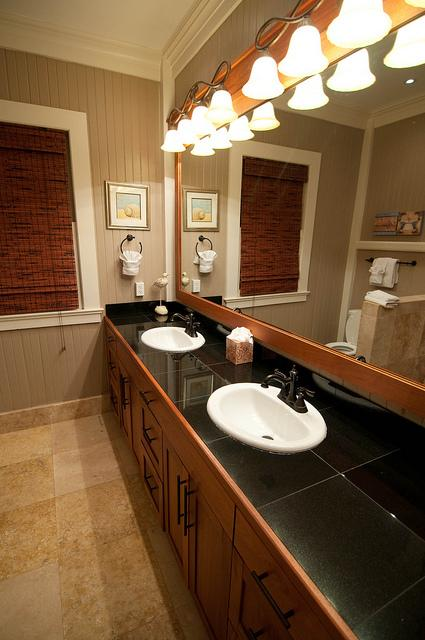What color are the sinks embedded in the black tile countertop? white 